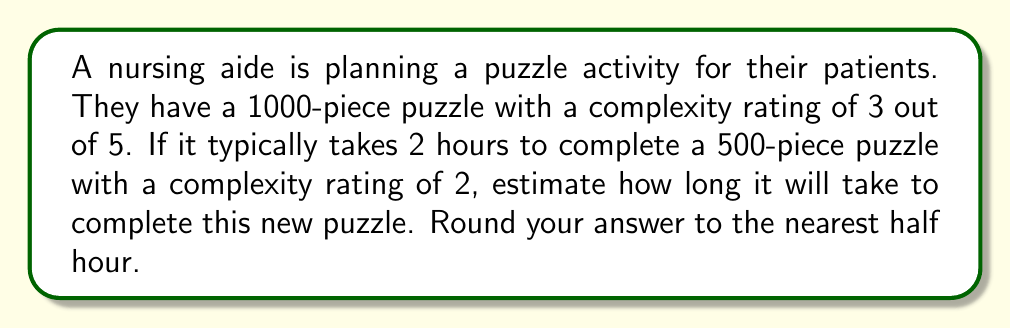Solve this math problem. Let's approach this step-by-step:

1) First, let's establish a baseline:
   - 500 pieces, complexity 2, takes 2 hours

2) We need to adjust for both the number of pieces and the complexity:

   a) Adjusting for pieces:
      - The new puzzle has 1000 pieces, which is twice as many
      - If complexity remained the same, it would take twice as long
      - $2 \text{ hours} \times 2 = 4 \text{ hours}$

   b) Adjusting for complexity:
      - The complexity increased from 2 to 3
      - This is a 50% increase in complexity
      - We can estimate that this will increase the time by 50%
      - $4 \text{ hours} \times 1.5 = 6 \text{ hours}$

3) Our estimate is now 6 hours

4) Rounding to the nearest half hour:
   6 hours is already a whole number, so no rounding is necessary

Therefore, we estimate it will take 6 hours to complete the new puzzle.
Answer: 6 hours 